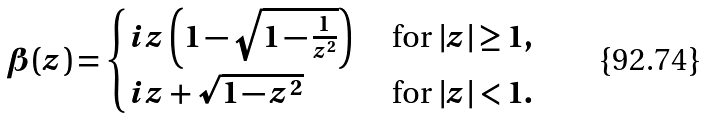Convert formula to latex. <formula><loc_0><loc_0><loc_500><loc_500>\beta ( z ) = \begin{cases} i z \left ( 1 - \sqrt { 1 - \frac { 1 } { z ^ { 2 } } } \right ) & \text { for $|z|     \geq 1$} , \\ i z + \sqrt { 1 - z ^ { 2 } } & \text { for $|z| < 1$} . \end{cases}</formula> 